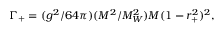Convert formula to latex. <formula><loc_0><loc_0><loc_500><loc_500>\Gamma _ { + } = ( g ^ { 2 } / 6 4 \pi ) ( M ^ { 2 } / M _ { W } ^ { 2 } ) M ( 1 - r _ { + } ^ { 2 } ) ^ { 2 } ,</formula> 